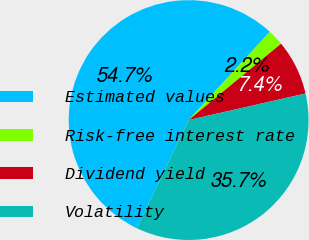<chart> <loc_0><loc_0><loc_500><loc_500><pie_chart><fcel>Estimated values<fcel>Risk-free interest rate<fcel>Dividend yield<fcel>Volatility<nl><fcel>54.74%<fcel>2.17%<fcel>7.43%<fcel>35.66%<nl></chart> 